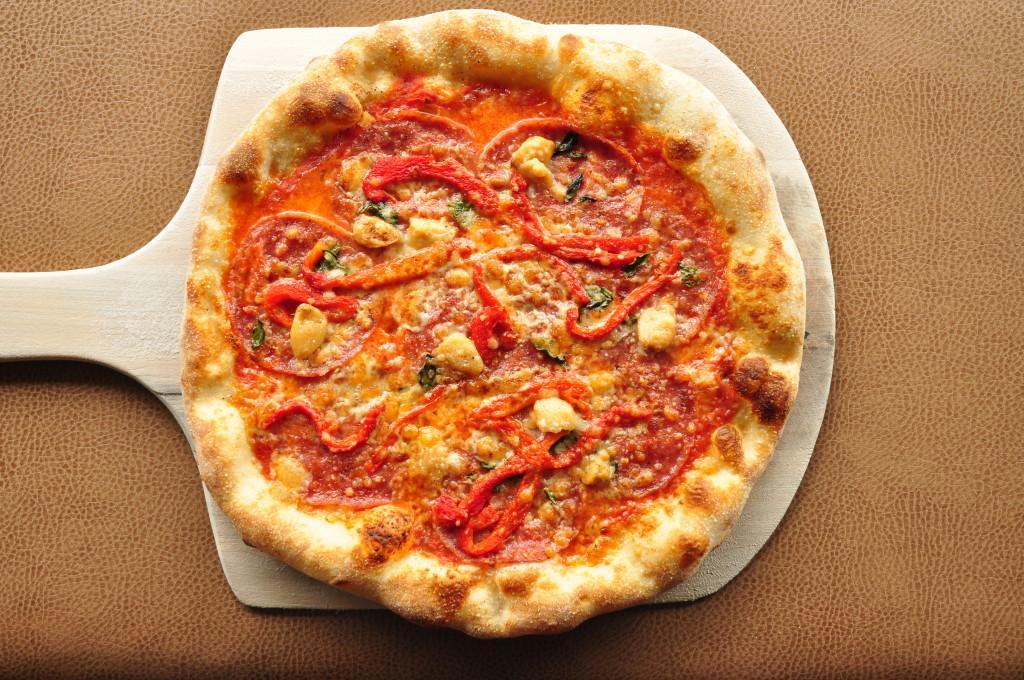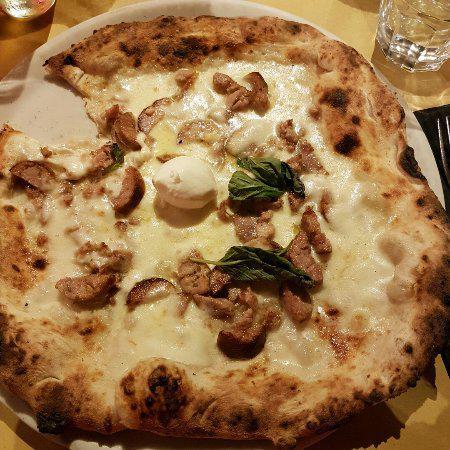The first image is the image on the left, the second image is the image on the right. Assess this claim about the two images: "There are two pizza and none of them are in a cardboard box.". Correct or not? Answer yes or no. Yes. The first image is the image on the left, the second image is the image on the right. For the images shown, is this caption "A piece of pizza is missing." true? Answer yes or no. Yes. 